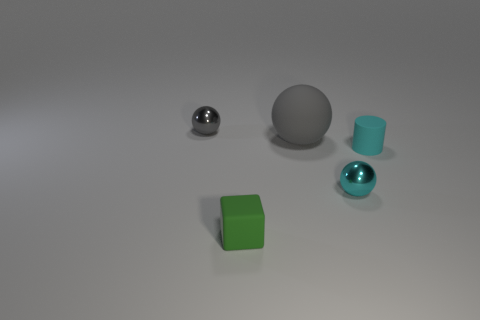Add 4 tiny cyan rubber cylinders. How many objects exist? 9 Subtract all small spheres. How many spheres are left? 1 Subtract 1 spheres. How many spheres are left? 2 Subtract all cylinders. How many objects are left? 4 Add 5 small blue spheres. How many small blue spheres exist? 5 Subtract 0 blue cubes. How many objects are left? 5 Subtract all small purple balls. Subtract all tiny gray metallic spheres. How many objects are left? 4 Add 4 cylinders. How many cylinders are left? 5 